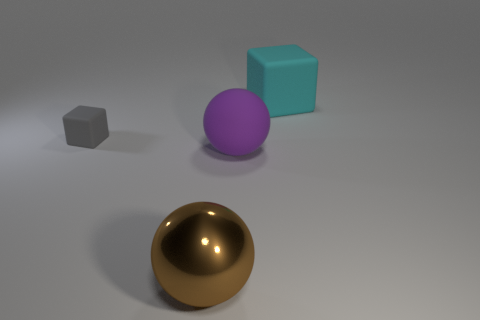The large cyan rubber object has what shape?
Keep it short and to the point. Cube. Is the material of the block on the left side of the big cube the same as the large ball to the right of the large metallic ball?
Keep it short and to the point. Yes. There is a block to the left of the large purple matte object; what is its size?
Provide a short and direct response. Small. There is another large purple thing that is the same shape as the big metallic thing; what is it made of?
Offer a terse response. Rubber. Is there any other thing that is the same size as the gray rubber cube?
Keep it short and to the point. No. There is a large thing in front of the purple rubber object; what is its shape?
Provide a succinct answer. Sphere. What number of large cyan matte objects are the same shape as the purple matte object?
Your response must be concise. 0. Are there the same number of brown things that are in front of the big brown ball and brown spheres that are on the left side of the big purple object?
Keep it short and to the point. No. Is there another cyan block made of the same material as the big cyan cube?
Make the answer very short. No. Is the material of the large brown thing the same as the small object?
Your answer should be very brief. No. 